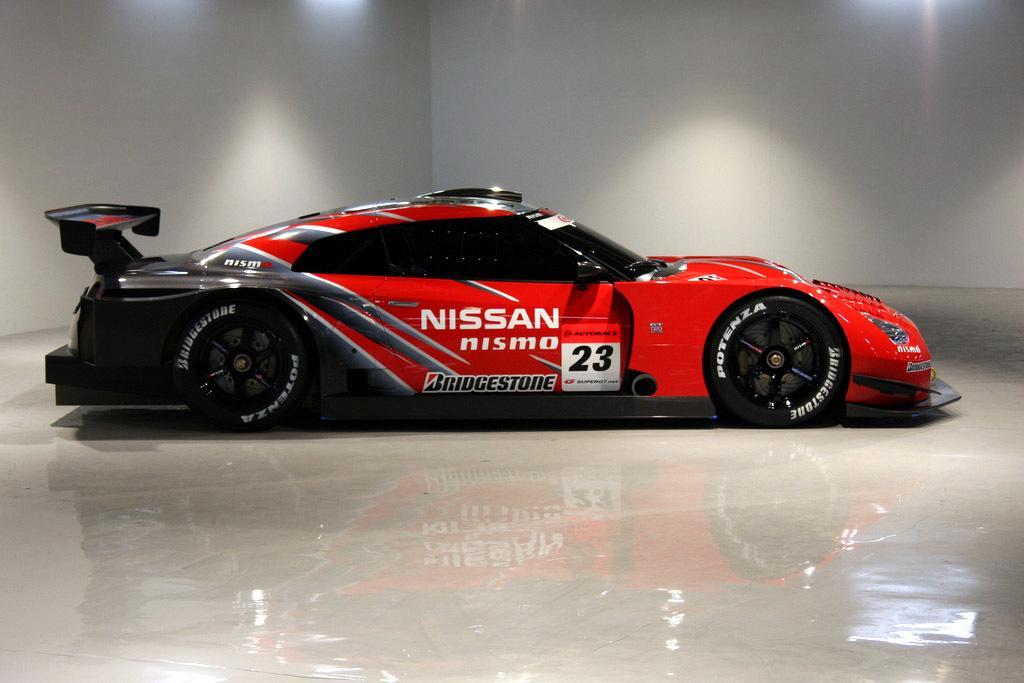Can you describe this image briefly? In this image there is a car on the floor, there is text on the car, there is a number on the car, there is a wall towards the top of the image, there are light rays towards the top of the image. 